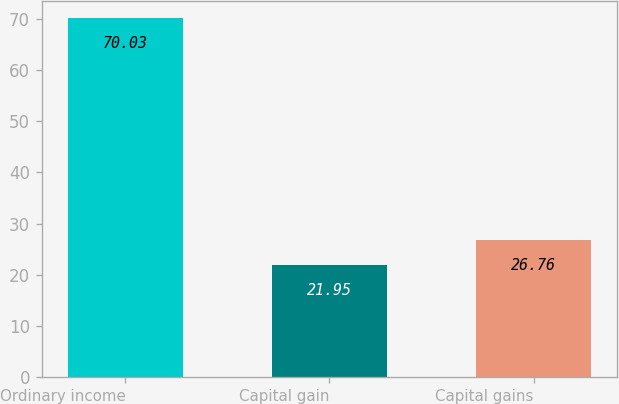<chart> <loc_0><loc_0><loc_500><loc_500><bar_chart><fcel>Ordinary income<fcel>Capital gain<fcel>Capital gains<nl><fcel>70.03<fcel>21.95<fcel>26.76<nl></chart> 